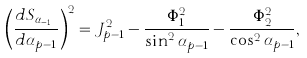<formula> <loc_0><loc_0><loc_500><loc_500>\left ( \frac { d S _ { \alpha _ { p - 1 } } } { d \alpha _ { p - 1 } } \right ) ^ { 2 } = J _ { p - 1 } ^ { 2 } - \frac { \Phi _ { 1 } ^ { 2 } } { \sin ^ { 2 } \alpha _ { p - 1 } } - \frac { \Phi _ { 2 } ^ { 2 } } { \cos ^ { 2 } \alpha _ { p - 1 } } ,</formula> 